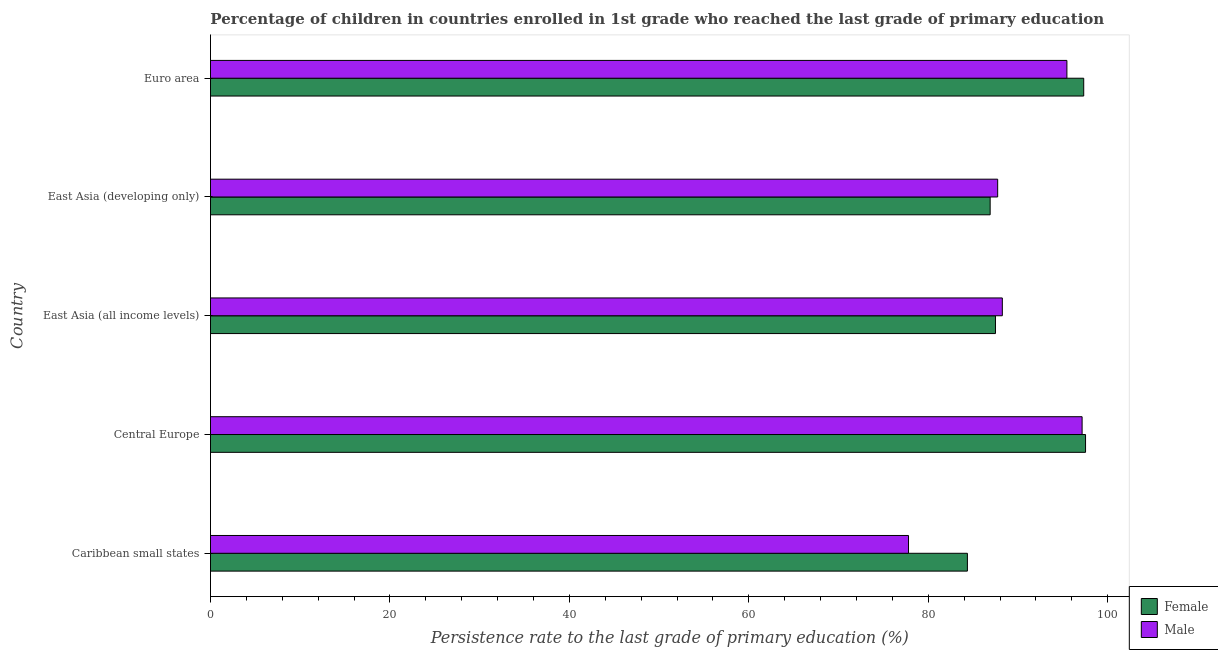How many different coloured bars are there?
Ensure brevity in your answer.  2. In how many cases, is the number of bars for a given country not equal to the number of legend labels?
Your answer should be compact. 0. What is the persistence rate of male students in East Asia (all income levels)?
Keep it short and to the point. 88.25. Across all countries, what is the maximum persistence rate of male students?
Keep it short and to the point. 97.14. Across all countries, what is the minimum persistence rate of female students?
Your answer should be compact. 84.36. In which country was the persistence rate of female students maximum?
Make the answer very short. Central Europe. In which country was the persistence rate of male students minimum?
Your answer should be very brief. Caribbean small states. What is the total persistence rate of female students in the graph?
Your answer should be very brief. 453.57. What is the difference between the persistence rate of male students in East Asia (developing only) and that in Euro area?
Provide a succinct answer. -7.72. What is the difference between the persistence rate of male students in Central Europe and the persistence rate of female students in East Asia (developing only)?
Your response must be concise. 10.25. What is the average persistence rate of male students per country?
Make the answer very short. 89.27. What is the difference between the persistence rate of male students and persistence rate of female students in East Asia (developing only)?
Your response must be concise. 0.84. In how many countries, is the persistence rate of female students greater than 52 %?
Provide a short and direct response. 5. What is the difference between the highest and the second highest persistence rate of male students?
Keep it short and to the point. 1.7. What is the difference between the highest and the lowest persistence rate of male students?
Offer a terse response. 19.35. Is the sum of the persistence rate of female students in Caribbean small states and Euro area greater than the maximum persistence rate of male students across all countries?
Give a very brief answer. Yes. What does the 2nd bar from the top in Euro area represents?
Your answer should be very brief. Female. Are all the bars in the graph horizontal?
Make the answer very short. Yes. Are the values on the major ticks of X-axis written in scientific E-notation?
Make the answer very short. No. How many legend labels are there?
Your answer should be compact. 2. What is the title of the graph?
Your answer should be compact. Percentage of children in countries enrolled in 1st grade who reached the last grade of primary education. Does "Diesel" appear as one of the legend labels in the graph?
Provide a short and direct response. No. What is the label or title of the X-axis?
Ensure brevity in your answer.  Persistence rate to the last grade of primary education (%). What is the label or title of the Y-axis?
Your answer should be compact. Country. What is the Persistence rate to the last grade of primary education (%) in Female in Caribbean small states?
Your response must be concise. 84.36. What is the Persistence rate to the last grade of primary education (%) of Male in Caribbean small states?
Make the answer very short. 77.79. What is the Persistence rate to the last grade of primary education (%) of Female in Central Europe?
Offer a very short reply. 97.52. What is the Persistence rate to the last grade of primary education (%) of Male in Central Europe?
Your answer should be very brief. 97.14. What is the Persistence rate to the last grade of primary education (%) of Female in East Asia (all income levels)?
Keep it short and to the point. 87.48. What is the Persistence rate to the last grade of primary education (%) of Male in East Asia (all income levels)?
Offer a very short reply. 88.25. What is the Persistence rate to the last grade of primary education (%) in Female in East Asia (developing only)?
Give a very brief answer. 86.89. What is the Persistence rate to the last grade of primary education (%) of Male in East Asia (developing only)?
Your answer should be very brief. 87.73. What is the Persistence rate to the last grade of primary education (%) in Female in Euro area?
Keep it short and to the point. 97.32. What is the Persistence rate to the last grade of primary education (%) of Male in Euro area?
Provide a succinct answer. 95.45. Across all countries, what is the maximum Persistence rate to the last grade of primary education (%) of Female?
Provide a short and direct response. 97.52. Across all countries, what is the maximum Persistence rate to the last grade of primary education (%) in Male?
Provide a short and direct response. 97.14. Across all countries, what is the minimum Persistence rate to the last grade of primary education (%) in Female?
Provide a short and direct response. 84.36. Across all countries, what is the minimum Persistence rate to the last grade of primary education (%) in Male?
Offer a very short reply. 77.79. What is the total Persistence rate to the last grade of primary education (%) of Female in the graph?
Provide a short and direct response. 453.57. What is the total Persistence rate to the last grade of primary education (%) of Male in the graph?
Your answer should be compact. 446.36. What is the difference between the Persistence rate to the last grade of primary education (%) in Female in Caribbean small states and that in Central Europe?
Ensure brevity in your answer.  -13.17. What is the difference between the Persistence rate to the last grade of primary education (%) of Male in Caribbean small states and that in Central Europe?
Ensure brevity in your answer.  -19.35. What is the difference between the Persistence rate to the last grade of primary education (%) of Female in Caribbean small states and that in East Asia (all income levels)?
Your answer should be compact. -3.13. What is the difference between the Persistence rate to the last grade of primary education (%) of Male in Caribbean small states and that in East Asia (all income levels)?
Offer a terse response. -10.46. What is the difference between the Persistence rate to the last grade of primary education (%) in Female in Caribbean small states and that in East Asia (developing only)?
Ensure brevity in your answer.  -2.54. What is the difference between the Persistence rate to the last grade of primary education (%) in Male in Caribbean small states and that in East Asia (developing only)?
Provide a succinct answer. -9.94. What is the difference between the Persistence rate to the last grade of primary education (%) of Female in Caribbean small states and that in Euro area?
Provide a succinct answer. -12.96. What is the difference between the Persistence rate to the last grade of primary education (%) of Male in Caribbean small states and that in Euro area?
Your response must be concise. -17.65. What is the difference between the Persistence rate to the last grade of primary education (%) in Female in Central Europe and that in East Asia (all income levels)?
Provide a succinct answer. 10.04. What is the difference between the Persistence rate to the last grade of primary education (%) of Male in Central Europe and that in East Asia (all income levels)?
Offer a terse response. 8.89. What is the difference between the Persistence rate to the last grade of primary education (%) in Female in Central Europe and that in East Asia (developing only)?
Give a very brief answer. 10.63. What is the difference between the Persistence rate to the last grade of primary education (%) in Male in Central Europe and that in East Asia (developing only)?
Keep it short and to the point. 9.41. What is the difference between the Persistence rate to the last grade of primary education (%) of Female in Central Europe and that in Euro area?
Keep it short and to the point. 0.2. What is the difference between the Persistence rate to the last grade of primary education (%) in Male in Central Europe and that in Euro area?
Give a very brief answer. 1.7. What is the difference between the Persistence rate to the last grade of primary education (%) in Female in East Asia (all income levels) and that in East Asia (developing only)?
Your response must be concise. 0.59. What is the difference between the Persistence rate to the last grade of primary education (%) of Male in East Asia (all income levels) and that in East Asia (developing only)?
Give a very brief answer. 0.52. What is the difference between the Persistence rate to the last grade of primary education (%) in Female in East Asia (all income levels) and that in Euro area?
Offer a terse response. -9.83. What is the difference between the Persistence rate to the last grade of primary education (%) in Male in East Asia (all income levels) and that in Euro area?
Provide a succinct answer. -7.2. What is the difference between the Persistence rate to the last grade of primary education (%) of Female in East Asia (developing only) and that in Euro area?
Give a very brief answer. -10.43. What is the difference between the Persistence rate to the last grade of primary education (%) in Male in East Asia (developing only) and that in Euro area?
Ensure brevity in your answer.  -7.72. What is the difference between the Persistence rate to the last grade of primary education (%) in Female in Caribbean small states and the Persistence rate to the last grade of primary education (%) in Male in Central Europe?
Offer a terse response. -12.78. What is the difference between the Persistence rate to the last grade of primary education (%) in Female in Caribbean small states and the Persistence rate to the last grade of primary education (%) in Male in East Asia (all income levels)?
Your answer should be very brief. -3.89. What is the difference between the Persistence rate to the last grade of primary education (%) in Female in Caribbean small states and the Persistence rate to the last grade of primary education (%) in Male in East Asia (developing only)?
Make the answer very short. -3.37. What is the difference between the Persistence rate to the last grade of primary education (%) of Female in Caribbean small states and the Persistence rate to the last grade of primary education (%) of Male in Euro area?
Offer a very short reply. -11.09. What is the difference between the Persistence rate to the last grade of primary education (%) of Female in Central Europe and the Persistence rate to the last grade of primary education (%) of Male in East Asia (all income levels)?
Ensure brevity in your answer.  9.27. What is the difference between the Persistence rate to the last grade of primary education (%) in Female in Central Europe and the Persistence rate to the last grade of primary education (%) in Male in East Asia (developing only)?
Offer a terse response. 9.79. What is the difference between the Persistence rate to the last grade of primary education (%) of Female in Central Europe and the Persistence rate to the last grade of primary education (%) of Male in Euro area?
Your answer should be very brief. 2.08. What is the difference between the Persistence rate to the last grade of primary education (%) in Female in East Asia (all income levels) and the Persistence rate to the last grade of primary education (%) in Male in East Asia (developing only)?
Keep it short and to the point. -0.24. What is the difference between the Persistence rate to the last grade of primary education (%) in Female in East Asia (all income levels) and the Persistence rate to the last grade of primary education (%) in Male in Euro area?
Your response must be concise. -7.96. What is the difference between the Persistence rate to the last grade of primary education (%) of Female in East Asia (developing only) and the Persistence rate to the last grade of primary education (%) of Male in Euro area?
Provide a short and direct response. -8.55. What is the average Persistence rate to the last grade of primary education (%) of Female per country?
Make the answer very short. 90.71. What is the average Persistence rate to the last grade of primary education (%) of Male per country?
Ensure brevity in your answer.  89.27. What is the difference between the Persistence rate to the last grade of primary education (%) in Female and Persistence rate to the last grade of primary education (%) in Male in Caribbean small states?
Offer a very short reply. 6.56. What is the difference between the Persistence rate to the last grade of primary education (%) of Female and Persistence rate to the last grade of primary education (%) of Male in Central Europe?
Your response must be concise. 0.38. What is the difference between the Persistence rate to the last grade of primary education (%) of Female and Persistence rate to the last grade of primary education (%) of Male in East Asia (all income levels)?
Offer a very short reply. -0.77. What is the difference between the Persistence rate to the last grade of primary education (%) of Female and Persistence rate to the last grade of primary education (%) of Male in East Asia (developing only)?
Keep it short and to the point. -0.84. What is the difference between the Persistence rate to the last grade of primary education (%) in Female and Persistence rate to the last grade of primary education (%) in Male in Euro area?
Ensure brevity in your answer.  1.87. What is the ratio of the Persistence rate to the last grade of primary education (%) of Female in Caribbean small states to that in Central Europe?
Offer a very short reply. 0.86. What is the ratio of the Persistence rate to the last grade of primary education (%) in Male in Caribbean small states to that in Central Europe?
Your answer should be very brief. 0.8. What is the ratio of the Persistence rate to the last grade of primary education (%) in Female in Caribbean small states to that in East Asia (all income levels)?
Offer a terse response. 0.96. What is the ratio of the Persistence rate to the last grade of primary education (%) in Male in Caribbean small states to that in East Asia (all income levels)?
Provide a succinct answer. 0.88. What is the ratio of the Persistence rate to the last grade of primary education (%) in Female in Caribbean small states to that in East Asia (developing only)?
Offer a very short reply. 0.97. What is the ratio of the Persistence rate to the last grade of primary education (%) in Male in Caribbean small states to that in East Asia (developing only)?
Offer a terse response. 0.89. What is the ratio of the Persistence rate to the last grade of primary education (%) in Female in Caribbean small states to that in Euro area?
Your answer should be compact. 0.87. What is the ratio of the Persistence rate to the last grade of primary education (%) of Male in Caribbean small states to that in Euro area?
Offer a terse response. 0.82. What is the ratio of the Persistence rate to the last grade of primary education (%) of Female in Central Europe to that in East Asia (all income levels)?
Ensure brevity in your answer.  1.11. What is the ratio of the Persistence rate to the last grade of primary education (%) in Male in Central Europe to that in East Asia (all income levels)?
Your response must be concise. 1.1. What is the ratio of the Persistence rate to the last grade of primary education (%) in Female in Central Europe to that in East Asia (developing only)?
Provide a short and direct response. 1.12. What is the ratio of the Persistence rate to the last grade of primary education (%) of Male in Central Europe to that in East Asia (developing only)?
Your answer should be compact. 1.11. What is the ratio of the Persistence rate to the last grade of primary education (%) in Female in Central Europe to that in Euro area?
Keep it short and to the point. 1. What is the ratio of the Persistence rate to the last grade of primary education (%) in Male in Central Europe to that in Euro area?
Your response must be concise. 1.02. What is the ratio of the Persistence rate to the last grade of primary education (%) in Female in East Asia (all income levels) to that in East Asia (developing only)?
Provide a short and direct response. 1.01. What is the ratio of the Persistence rate to the last grade of primary education (%) in Male in East Asia (all income levels) to that in East Asia (developing only)?
Your response must be concise. 1.01. What is the ratio of the Persistence rate to the last grade of primary education (%) in Female in East Asia (all income levels) to that in Euro area?
Your answer should be compact. 0.9. What is the ratio of the Persistence rate to the last grade of primary education (%) in Male in East Asia (all income levels) to that in Euro area?
Provide a succinct answer. 0.92. What is the ratio of the Persistence rate to the last grade of primary education (%) of Female in East Asia (developing only) to that in Euro area?
Provide a succinct answer. 0.89. What is the ratio of the Persistence rate to the last grade of primary education (%) of Male in East Asia (developing only) to that in Euro area?
Your answer should be very brief. 0.92. What is the difference between the highest and the second highest Persistence rate to the last grade of primary education (%) in Female?
Offer a very short reply. 0.2. What is the difference between the highest and the second highest Persistence rate to the last grade of primary education (%) in Male?
Your answer should be very brief. 1.7. What is the difference between the highest and the lowest Persistence rate to the last grade of primary education (%) of Female?
Offer a very short reply. 13.17. What is the difference between the highest and the lowest Persistence rate to the last grade of primary education (%) in Male?
Make the answer very short. 19.35. 